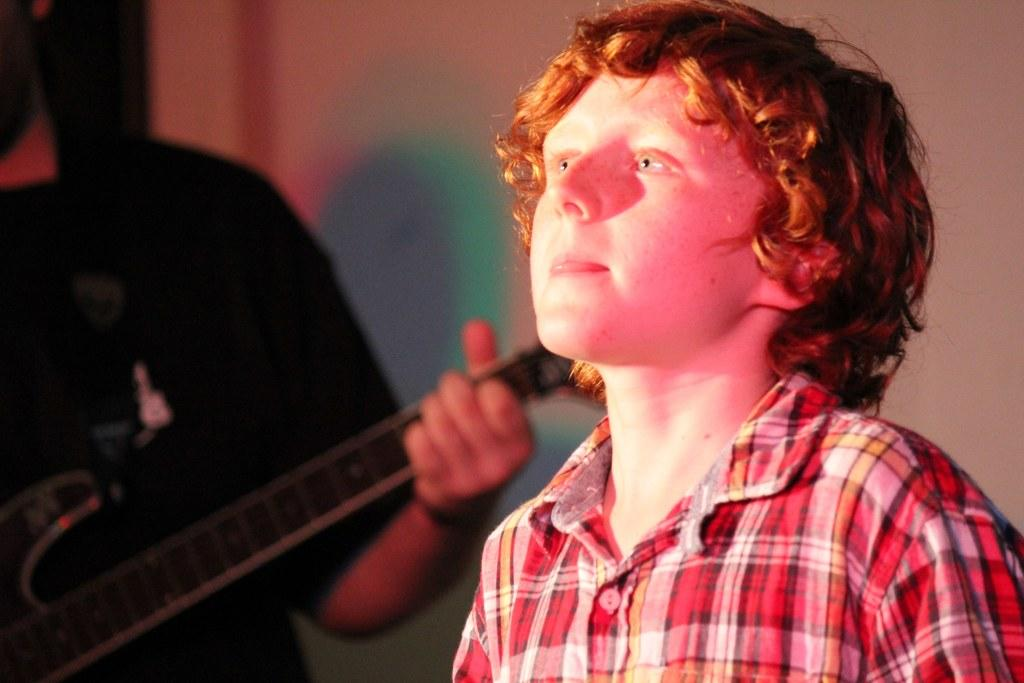What is the main subject of the image? The main subject of the image is a boy. What is the boy wearing in the image? The boy is wearing a red color shirt in the image. What activity is happening in the background of the image? There is a person playing guitar in the background of the image. What is behind the boy in the image? There is a wall behind the boy in the image. What type of work is being done at the desk in the image? There is no desk present in the image. Can you tell me how many church bells are visible in the image? There are no church bells or any reference to a church in the image. 